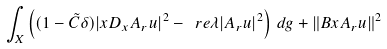<formula> <loc_0><loc_0><loc_500><loc_500>\int _ { X } \left ( ( 1 - \tilde { C } \delta ) | x D _ { x } A _ { r } u | ^ { 2 } - \ r e \lambda | A _ { r } u | ^ { 2 } \right ) \, d g + \| B x A _ { r } u \| ^ { 2 }</formula> 